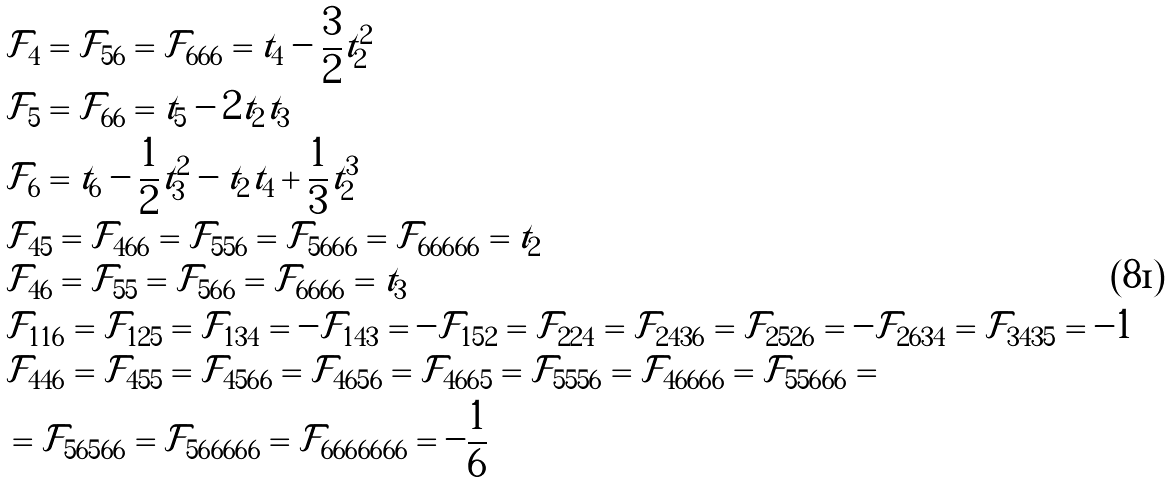<formula> <loc_0><loc_0><loc_500><loc_500>& \mathcal { F } _ { 4 } = \mathcal { F } _ { 5 6 } = \mathcal { F } _ { 6 6 6 } = t _ { 4 } - \frac { 3 } { 2 } t _ { 2 } ^ { 2 } \\ & \mathcal { F } _ { 5 } = \mathcal { F } _ { 6 6 } = t _ { 5 } - 2 t _ { 2 } t _ { 3 } \\ & \mathcal { F } _ { 6 } = t _ { 6 } - \frac { 1 } { 2 } t _ { 3 } ^ { 2 } - t _ { 2 } t _ { 4 } + \frac { 1 } { 3 } t _ { 2 } ^ { 3 } \\ & \mathcal { F } _ { 4 5 } = \mathcal { F } _ { 4 6 6 } = \mathcal { F } _ { 5 5 6 } = \mathcal { F } _ { 5 6 6 6 } = \mathcal { F } _ { 6 6 6 6 6 } = t _ { 2 } \\ & \mathcal { F } _ { 4 6 } = \mathcal { F } _ { 5 5 } = \mathcal { F } _ { 5 6 6 } = \mathcal { F } _ { 6 6 6 6 } = t _ { 3 } \\ & \mathcal { F } _ { 1 1 6 } = \mathcal { F } _ { 1 2 5 } = \mathcal { F } _ { 1 3 4 } = - \mathcal { F } _ { 1 4 3 } = - \mathcal { F } _ { 1 5 2 } = \mathcal { F } _ { 2 2 4 } = \mathcal { F } _ { 2 4 3 6 } = \mathcal { F } _ { 2 5 2 6 } = - \mathcal { F } _ { 2 6 3 4 } = \mathcal { F } _ { 3 4 3 5 } = - 1 \\ & \mathcal { F } _ { 4 4 6 } = \mathcal { F } _ { 4 5 5 } = \mathcal { F } _ { 4 5 6 6 } = \mathcal { F } _ { 4 6 5 6 } = \mathcal { F } _ { 4 6 6 5 } = \mathcal { F } _ { 5 5 5 6 } = \mathcal { F } _ { 4 6 6 6 6 } = \mathcal { F } _ { 5 5 6 6 6 } = \\ & = \mathcal { F } _ { 5 6 5 6 6 } = \mathcal { F } _ { 5 6 6 6 6 6 } = \mathcal { F } _ { 6 6 6 6 6 6 6 } = - \frac { 1 } { 6 }</formula> 